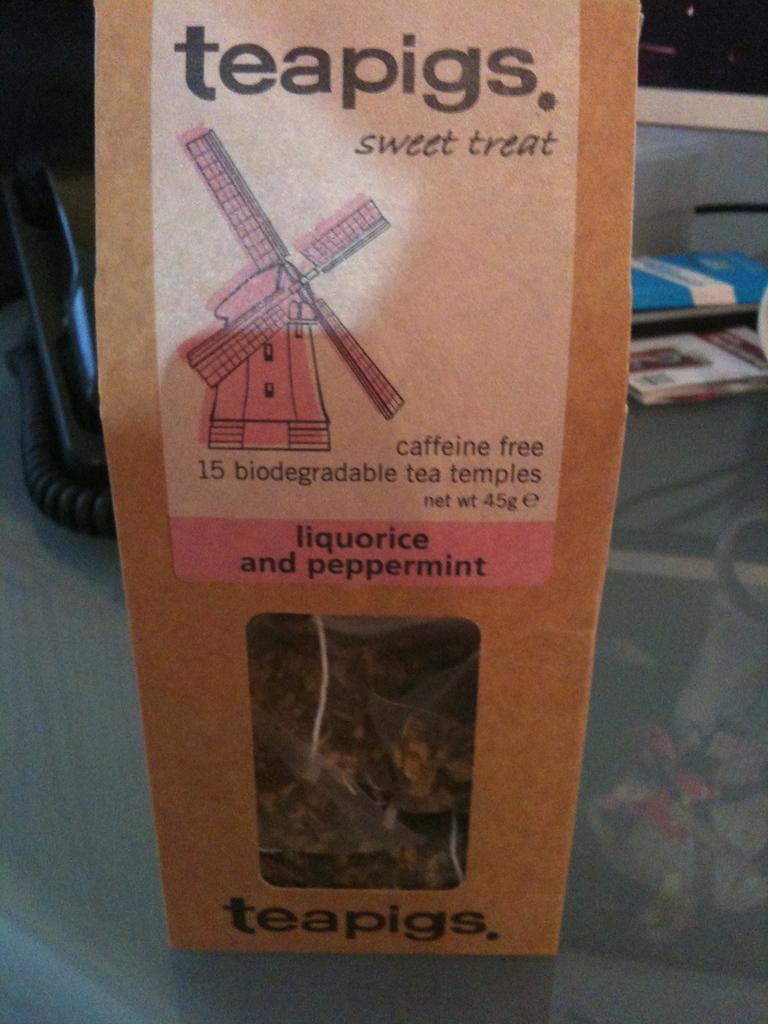What is a teapig?
Provide a succinct answer. Sweet treat. 